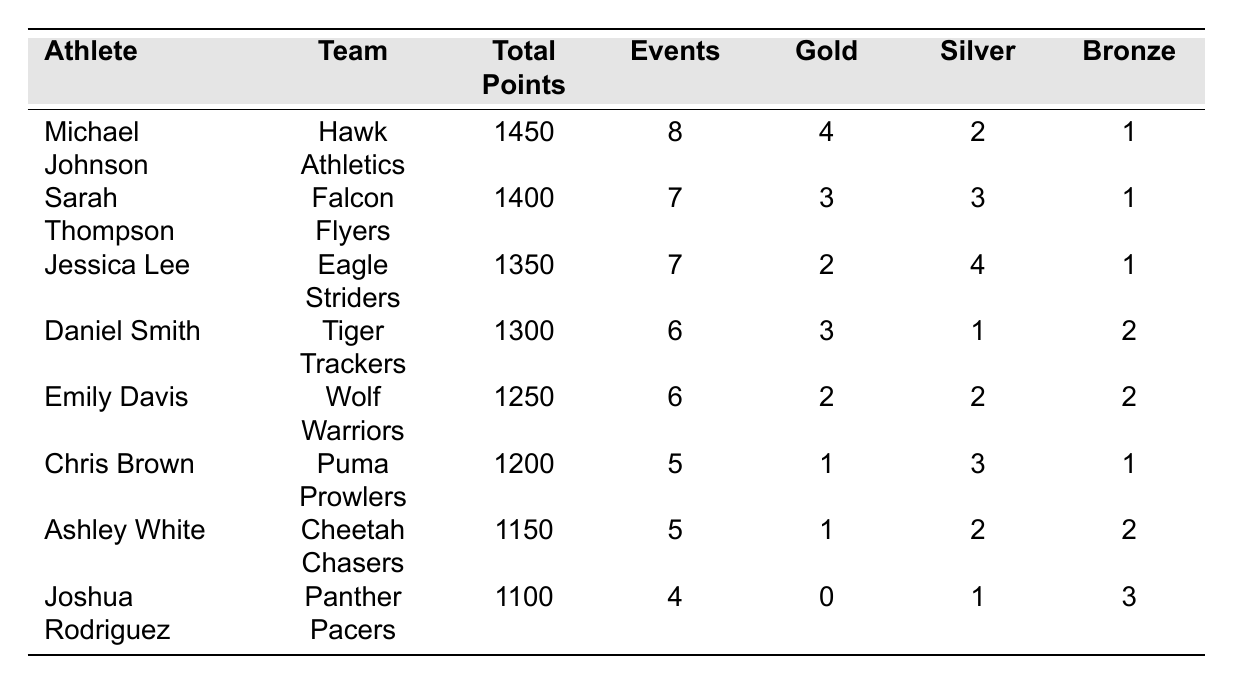What is the total number of gold medals won by Michael Johnson? The table shows that Michael Johnson won 4 gold medals.
Answer: 4 How many events did Jessica Lee participate in? Jessica Lee is listed in the table with 7 events participated.
Answer: 7 Which athlete participated in the fewest events? By checking the events column, Joshua Rodriguez participated in 4 events, which is the fewest.
Answer: Joshua Rodriguez What is the average total points of all athletes in the table? To find the average, sum the total points: 1450 + 1400 + 1350 + 1300 + 1250 + 1200 + 1150 + 1100 = 10,200. Then divide by 8 athletes: 10,200 / 8 = 1275.
Answer: 1275 Who won the most silver medals? By examining the silver medal counts in the table, Jessica Lee won 4 silver medals, which is the highest among all athletes.
Answer: Jessica Lee What is the difference in total points between the first and last-ranked athletes? Michael Johnson has 1450 total points, and Joshua Rodriguez has 1100. The difference is 1450 - 1100 = 350.
Answer: 350 Is Emily Davis among the top three athletes by total points? The top three athletes by total points are Michael Johnson, Sarah Thompson, and Jessica Lee, so Emily Davis is not among them.
Answer: No Which athlete has the most bronze medals? Reviewing the bronze medal column, Joshua Rodriguez and Emily Davis both have 3 bronze medals, making them tie for the most.
Answer: Joshua Rodriguez and Emily Davis If we combine the gold medals of Sarah Thompson and Daniel Smith, how many do they have in total? Sarah Thompson has 3 gold medals, Daniel Smith has 3 as well. Their total is 3 + 3 = 6 gold medals.
Answer: 6 Who is the only athlete without a gold medal? Looking through the table, Joshua Rodriguez has 0 gold medals.
Answer: Joshua Rodriguez 